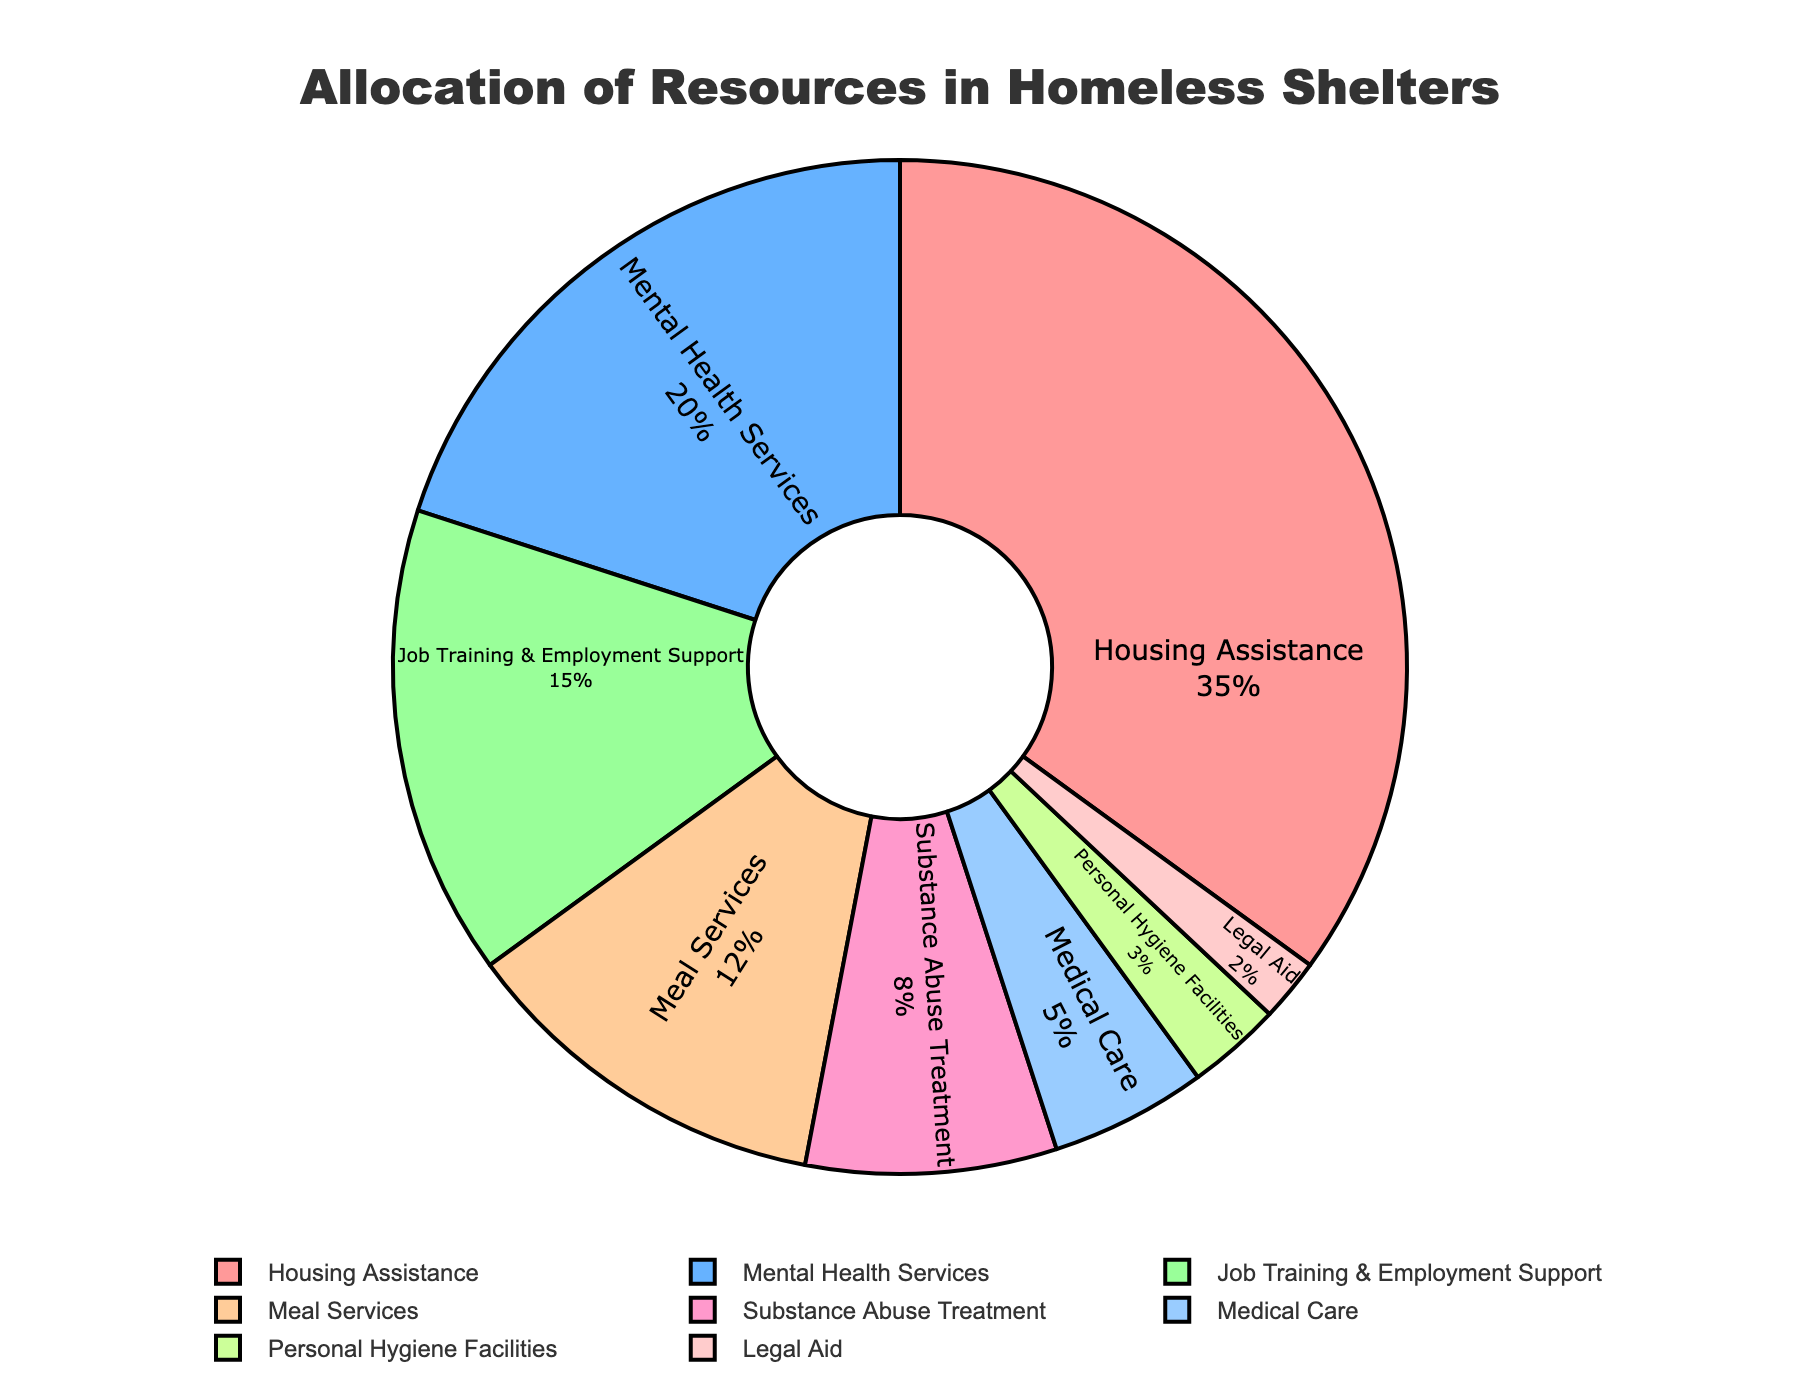What percentage of resources is allocated to Housing Assistance? The pie chart shows that 35% of the total resources are allocated to Housing Assistance.
Answer: 35% Which service type receives the least allocation of resources? The pie chart indicates that Legal Aid receives the least allocation of resources with 2%.
Answer: Legal Aid What is the combined percentage for Mental Health Services and Substance Abuse Treatment? The percentage for Mental Health Services is 20%, and for Substance Abuse Treatment, it is 8%. Adding them together: 20% + 8% = 28%.
Answer: 28% How does the resource allocation for Job Training & Employment Support compare to Medical Care? Job Training & Employment Support has 15% of the resources allocated, whereas Medical Care has 5%. 15% is greater than 5%.
Answer: Job Training & Employment Support has more What is the difference in resource allocation between Meal Services and Personal Hygiene Facilities? Meal Services receive 12% of the resources, and Personal Hygiene Facilities receive 3%. The difference is 12% - 3% = 9%.
Answer: 9% How does the allocation for Housing Assistance compare to the sum of Medical Care and Personal Hygiene Facilities? Housing Assistance is allocated 35%, while Medical Care and Personal Hygiene Facilities have 5% and 3% respectively. Adding Medical Care and Personal Hygiene Facilities: 5% + 3% = 8%. Housing Assistance (35%) is higher than this sum (8%).
Answer: Housing Assistance is higher What is the total percentage allocated to service types related to health (Mental Health Services, Substance Abuse Treatment, and Medical Care)? Mental Health Services are allocated 20%, Substance Abuse Treatment 8%, and Medical Care 5%. Adding these: 20% + 8% + 5% = 33%.
Answer: 33% Which services have more than 10% of resources allocated to them? By looking at the pie chart, Housing Assistance (35%), Mental Health Services (20%), Job Training & Employment Support (15%), and Meal Services (12%) each have more than 10% allocated.
Answer: Housing Assistance, Mental Health Services, Job Training & Employment Support, Meal Services 